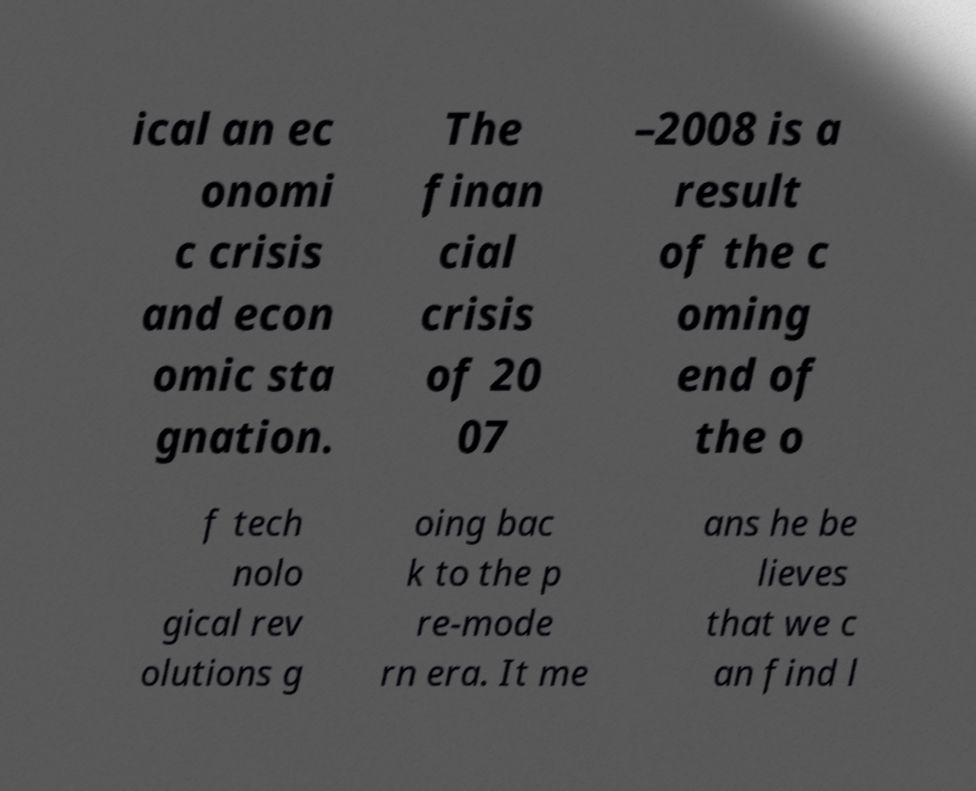I need the written content from this picture converted into text. Can you do that? ical an ec onomi c crisis and econ omic sta gnation. The finan cial crisis of 20 07 –2008 is a result of the c oming end of the o f tech nolo gical rev olutions g oing bac k to the p re-mode rn era. It me ans he be lieves that we c an find l 